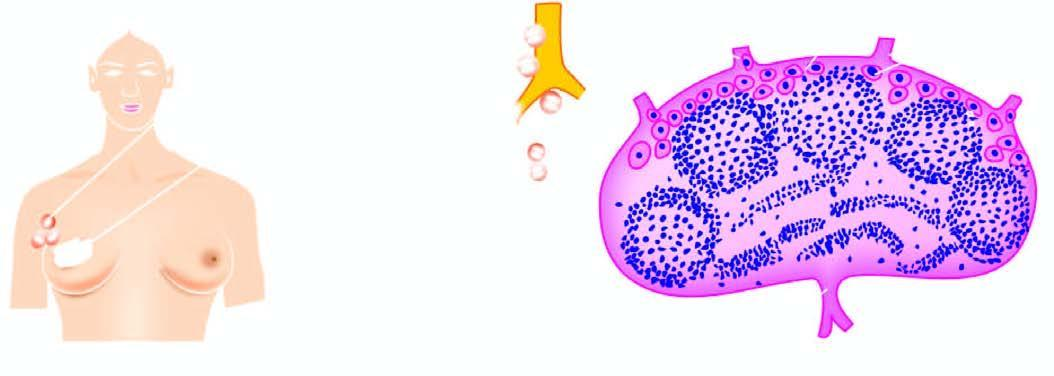does lymphatic spread begin by lodgement of tumour cells in subcapsular sinus via afferent lymphatics entering at the convex surface of the lymph node?
Answer the question using a single word or phrase. Yes 